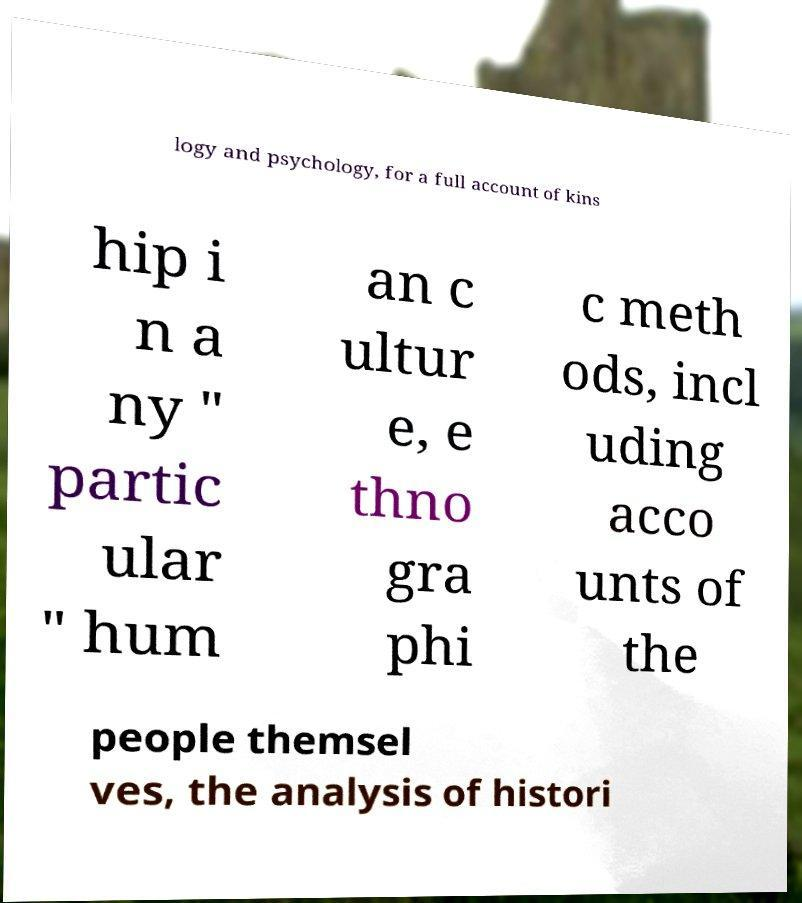Could you assist in decoding the text presented in this image and type it out clearly? logy and psychology, for a full account of kins hip i n a ny " partic ular " hum an c ultur e, e thno gra phi c meth ods, incl uding acco unts of the people themsel ves, the analysis of histori 